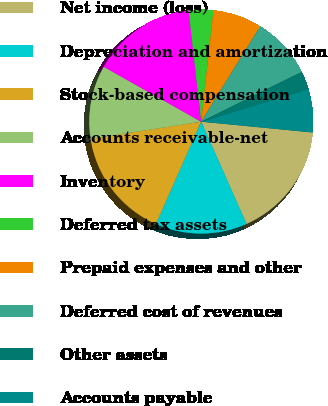<chart> <loc_0><loc_0><loc_500><loc_500><pie_chart><fcel>Net income (loss)<fcel>Depreciation and amortization<fcel>Stock-based compensation<fcel>Accounts receivable-net<fcel>Inventory<fcel>Deferred tax assets<fcel>Prepaid expenses and other<fcel>Deferred cost of revenues<fcel>Other assets<fcel>Accounts payable<nl><fcel>16.81%<fcel>13.27%<fcel>15.93%<fcel>10.62%<fcel>15.04%<fcel>3.54%<fcel>7.08%<fcel>8.85%<fcel>2.66%<fcel>6.2%<nl></chart> 